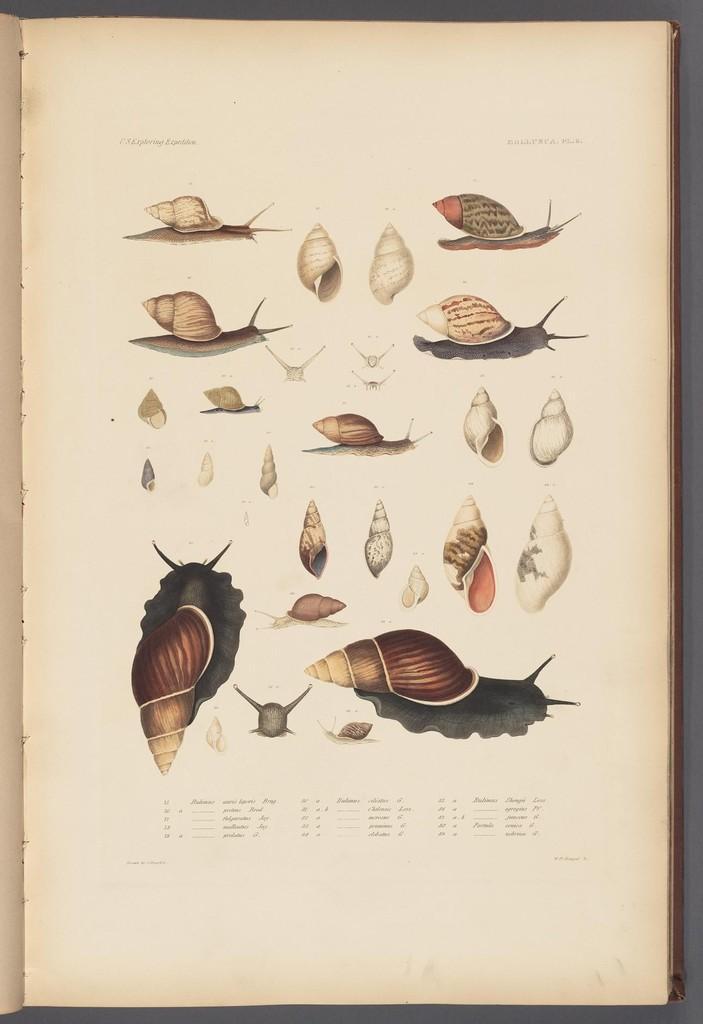Please provide a concise description of this image. In this image we can see one one book with text and images on the white surface. 